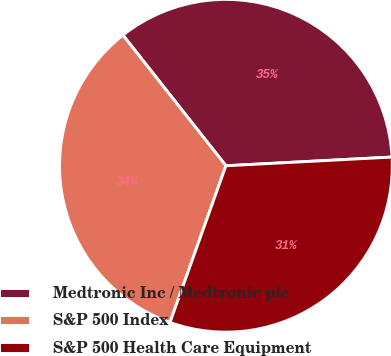<chart> <loc_0><loc_0><loc_500><loc_500><pie_chart><fcel>Medtronic Inc / Medtronic plc<fcel>S&P 500 Index<fcel>S&P 500 Health Care Equipment<nl><fcel>34.79%<fcel>33.92%<fcel>31.29%<nl></chart> 